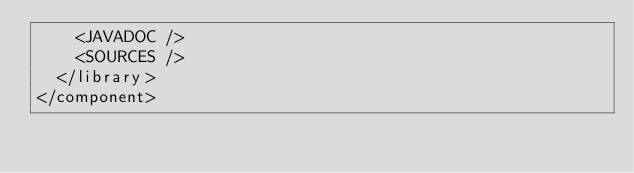Convert code to text. <code><loc_0><loc_0><loc_500><loc_500><_XML_>    <JAVADOC />
    <SOURCES />
  </library>
</component>
</code> 